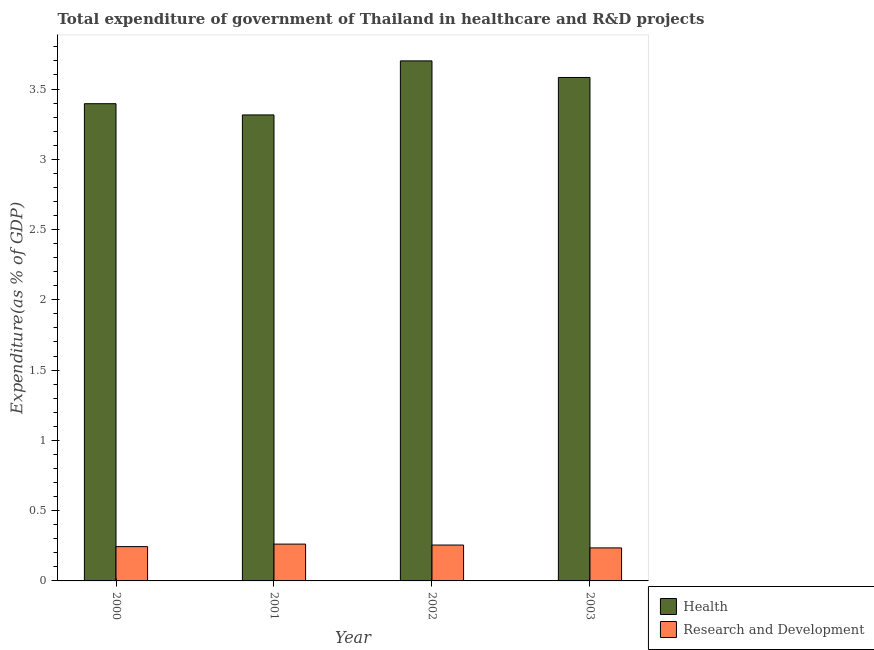How many groups of bars are there?
Keep it short and to the point. 4. How many bars are there on the 2nd tick from the right?
Provide a succinct answer. 2. In how many cases, is the number of bars for a given year not equal to the number of legend labels?
Make the answer very short. 0. What is the expenditure in healthcare in 2000?
Provide a succinct answer. 3.4. Across all years, what is the maximum expenditure in r&d?
Offer a terse response. 0.26. Across all years, what is the minimum expenditure in healthcare?
Your answer should be compact. 3.32. In which year was the expenditure in healthcare maximum?
Ensure brevity in your answer.  2002. In which year was the expenditure in healthcare minimum?
Offer a very short reply. 2001. What is the total expenditure in healthcare in the graph?
Offer a terse response. 13.99. What is the difference between the expenditure in healthcare in 2000 and that in 2002?
Ensure brevity in your answer.  -0.3. What is the difference between the expenditure in healthcare in 2003 and the expenditure in r&d in 2000?
Provide a short and direct response. 0.19. What is the average expenditure in r&d per year?
Offer a very short reply. 0.25. In the year 2000, what is the difference between the expenditure in healthcare and expenditure in r&d?
Offer a very short reply. 0. What is the ratio of the expenditure in healthcare in 2001 to that in 2002?
Your answer should be very brief. 0.9. Is the difference between the expenditure in r&d in 2000 and 2001 greater than the difference between the expenditure in healthcare in 2000 and 2001?
Your answer should be compact. No. What is the difference between the highest and the second highest expenditure in r&d?
Provide a short and direct response. 0.01. What is the difference between the highest and the lowest expenditure in healthcare?
Your answer should be very brief. 0.38. In how many years, is the expenditure in r&d greater than the average expenditure in r&d taken over all years?
Your answer should be compact. 2. Is the sum of the expenditure in r&d in 2001 and 2002 greater than the maximum expenditure in healthcare across all years?
Give a very brief answer. Yes. What does the 2nd bar from the left in 2001 represents?
Your answer should be very brief. Research and Development. What does the 1st bar from the right in 2000 represents?
Provide a short and direct response. Research and Development. How many years are there in the graph?
Provide a succinct answer. 4. What is the difference between two consecutive major ticks on the Y-axis?
Make the answer very short. 0.5. Where does the legend appear in the graph?
Make the answer very short. Bottom right. How many legend labels are there?
Your response must be concise. 2. How are the legend labels stacked?
Your response must be concise. Vertical. What is the title of the graph?
Keep it short and to the point. Total expenditure of government of Thailand in healthcare and R&D projects. Does "Male labourers" appear as one of the legend labels in the graph?
Your answer should be compact. No. What is the label or title of the Y-axis?
Give a very brief answer. Expenditure(as % of GDP). What is the Expenditure(as % of GDP) in Health in 2000?
Keep it short and to the point. 3.4. What is the Expenditure(as % of GDP) in Research and Development in 2000?
Your answer should be compact. 0.24. What is the Expenditure(as % of GDP) of Health in 2001?
Provide a succinct answer. 3.32. What is the Expenditure(as % of GDP) in Research and Development in 2001?
Make the answer very short. 0.26. What is the Expenditure(as % of GDP) in Health in 2002?
Offer a very short reply. 3.7. What is the Expenditure(as % of GDP) in Research and Development in 2002?
Keep it short and to the point. 0.26. What is the Expenditure(as % of GDP) in Health in 2003?
Your response must be concise. 3.58. What is the Expenditure(as % of GDP) of Research and Development in 2003?
Give a very brief answer. 0.23. Across all years, what is the maximum Expenditure(as % of GDP) in Health?
Your response must be concise. 3.7. Across all years, what is the maximum Expenditure(as % of GDP) in Research and Development?
Your response must be concise. 0.26. Across all years, what is the minimum Expenditure(as % of GDP) of Health?
Your answer should be compact. 3.32. Across all years, what is the minimum Expenditure(as % of GDP) of Research and Development?
Offer a very short reply. 0.23. What is the total Expenditure(as % of GDP) of Health in the graph?
Ensure brevity in your answer.  13.99. What is the total Expenditure(as % of GDP) in Research and Development in the graph?
Make the answer very short. 1. What is the difference between the Expenditure(as % of GDP) of Health in 2000 and that in 2001?
Offer a very short reply. 0.08. What is the difference between the Expenditure(as % of GDP) of Research and Development in 2000 and that in 2001?
Ensure brevity in your answer.  -0.02. What is the difference between the Expenditure(as % of GDP) in Health in 2000 and that in 2002?
Provide a succinct answer. -0.3. What is the difference between the Expenditure(as % of GDP) of Research and Development in 2000 and that in 2002?
Provide a short and direct response. -0.01. What is the difference between the Expenditure(as % of GDP) in Health in 2000 and that in 2003?
Offer a terse response. -0.19. What is the difference between the Expenditure(as % of GDP) of Research and Development in 2000 and that in 2003?
Provide a succinct answer. 0.01. What is the difference between the Expenditure(as % of GDP) in Health in 2001 and that in 2002?
Your answer should be very brief. -0.38. What is the difference between the Expenditure(as % of GDP) in Research and Development in 2001 and that in 2002?
Keep it short and to the point. 0.01. What is the difference between the Expenditure(as % of GDP) of Health in 2001 and that in 2003?
Give a very brief answer. -0.27. What is the difference between the Expenditure(as % of GDP) of Research and Development in 2001 and that in 2003?
Make the answer very short. 0.03. What is the difference between the Expenditure(as % of GDP) in Health in 2002 and that in 2003?
Offer a very short reply. 0.12. What is the difference between the Expenditure(as % of GDP) in Research and Development in 2002 and that in 2003?
Your response must be concise. 0.02. What is the difference between the Expenditure(as % of GDP) in Health in 2000 and the Expenditure(as % of GDP) in Research and Development in 2001?
Provide a succinct answer. 3.13. What is the difference between the Expenditure(as % of GDP) in Health in 2000 and the Expenditure(as % of GDP) in Research and Development in 2002?
Give a very brief answer. 3.14. What is the difference between the Expenditure(as % of GDP) in Health in 2000 and the Expenditure(as % of GDP) in Research and Development in 2003?
Give a very brief answer. 3.16. What is the difference between the Expenditure(as % of GDP) of Health in 2001 and the Expenditure(as % of GDP) of Research and Development in 2002?
Give a very brief answer. 3.06. What is the difference between the Expenditure(as % of GDP) of Health in 2001 and the Expenditure(as % of GDP) of Research and Development in 2003?
Your answer should be very brief. 3.08. What is the difference between the Expenditure(as % of GDP) in Health in 2002 and the Expenditure(as % of GDP) in Research and Development in 2003?
Provide a succinct answer. 3.47. What is the average Expenditure(as % of GDP) of Health per year?
Ensure brevity in your answer.  3.5. What is the average Expenditure(as % of GDP) in Research and Development per year?
Your response must be concise. 0.25. In the year 2000, what is the difference between the Expenditure(as % of GDP) in Health and Expenditure(as % of GDP) in Research and Development?
Your response must be concise. 3.15. In the year 2001, what is the difference between the Expenditure(as % of GDP) of Health and Expenditure(as % of GDP) of Research and Development?
Offer a terse response. 3.05. In the year 2002, what is the difference between the Expenditure(as % of GDP) in Health and Expenditure(as % of GDP) in Research and Development?
Provide a short and direct response. 3.44. In the year 2003, what is the difference between the Expenditure(as % of GDP) in Health and Expenditure(as % of GDP) in Research and Development?
Offer a very short reply. 3.35. What is the ratio of the Expenditure(as % of GDP) in Health in 2000 to that in 2001?
Offer a very short reply. 1.02. What is the ratio of the Expenditure(as % of GDP) in Research and Development in 2000 to that in 2001?
Provide a succinct answer. 0.93. What is the ratio of the Expenditure(as % of GDP) in Health in 2000 to that in 2002?
Provide a succinct answer. 0.92. What is the ratio of the Expenditure(as % of GDP) in Research and Development in 2000 to that in 2002?
Keep it short and to the point. 0.96. What is the ratio of the Expenditure(as % of GDP) in Health in 2000 to that in 2003?
Offer a terse response. 0.95. What is the ratio of the Expenditure(as % of GDP) of Research and Development in 2000 to that in 2003?
Your response must be concise. 1.04. What is the ratio of the Expenditure(as % of GDP) of Health in 2001 to that in 2002?
Provide a short and direct response. 0.9. What is the ratio of the Expenditure(as % of GDP) of Research and Development in 2001 to that in 2002?
Your answer should be very brief. 1.03. What is the ratio of the Expenditure(as % of GDP) of Health in 2001 to that in 2003?
Give a very brief answer. 0.93. What is the ratio of the Expenditure(as % of GDP) of Research and Development in 2001 to that in 2003?
Offer a terse response. 1.11. What is the ratio of the Expenditure(as % of GDP) of Health in 2002 to that in 2003?
Provide a succinct answer. 1.03. What is the ratio of the Expenditure(as % of GDP) in Research and Development in 2002 to that in 2003?
Give a very brief answer. 1.09. What is the difference between the highest and the second highest Expenditure(as % of GDP) of Health?
Your answer should be compact. 0.12. What is the difference between the highest and the second highest Expenditure(as % of GDP) of Research and Development?
Give a very brief answer. 0.01. What is the difference between the highest and the lowest Expenditure(as % of GDP) of Health?
Provide a succinct answer. 0.38. What is the difference between the highest and the lowest Expenditure(as % of GDP) in Research and Development?
Make the answer very short. 0.03. 